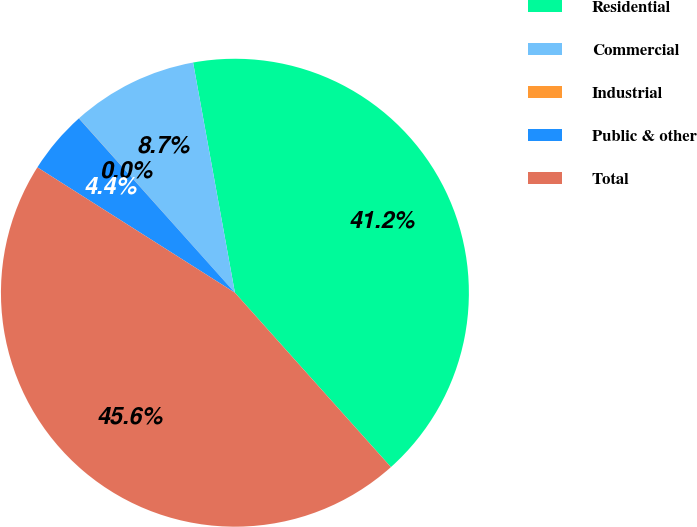<chart> <loc_0><loc_0><loc_500><loc_500><pie_chart><fcel>Residential<fcel>Commercial<fcel>Industrial<fcel>Public & other<fcel>Total<nl><fcel>41.25%<fcel>8.75%<fcel>0.01%<fcel>4.38%<fcel>45.62%<nl></chart> 